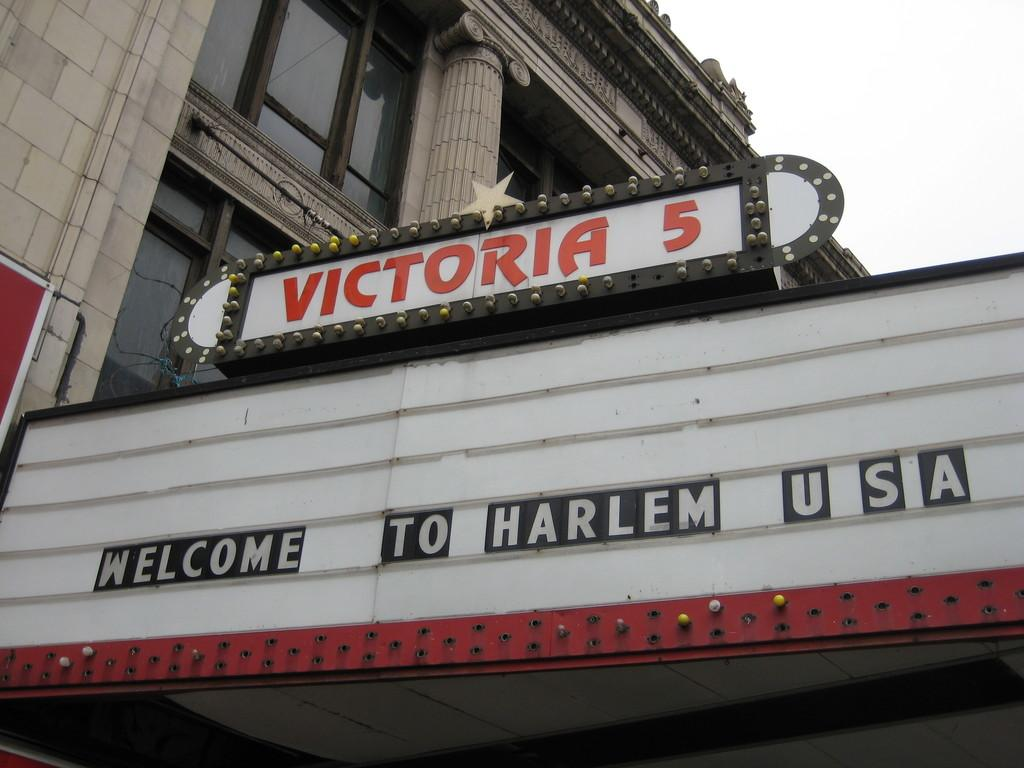What is the main subject of the image? The main subject of the image is a board of a building. What can be seen behind the board? There is a building behind the board. What type of windows does the building have? The building has glass windows. Is there a basketball fight happening in the image? No, there is no basketball fight or any reference to a basketball in the image. 